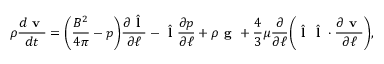Convert formula to latex. <formula><loc_0><loc_0><loc_500><loc_500>\rho \frac { d v } { d t } = \left ( \frac { B ^ { 2 } } { 4 \pi } - p \right ) \frac { \partial \hat { l } } { \partial \ell } - \hat { l } \frac { \partial p } { \partial \ell } + \rho g + \frac { 4 } { 3 } \mu \frac { \partial } { \partial \ell } \left ( \hat { l } \hat { l } \cdot \frac { \partial v } { \partial \ell } \right ) ,</formula> 